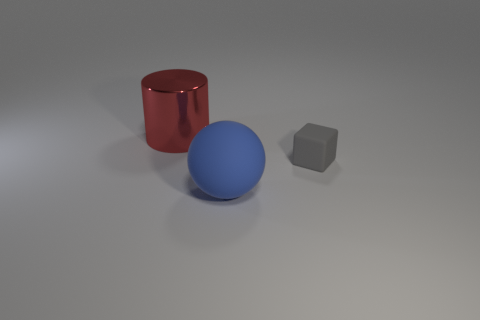Add 2 red metallic cylinders. How many objects exist? 5 Subtract all cubes. How many objects are left? 2 Add 1 big blue rubber things. How many big blue rubber things are left? 2 Add 2 tiny objects. How many tiny objects exist? 3 Subtract 0 yellow balls. How many objects are left? 3 Subtract all yellow cylinders. Subtract all brown blocks. How many cylinders are left? 1 Subtract all shiny cylinders. Subtract all big things. How many objects are left? 0 